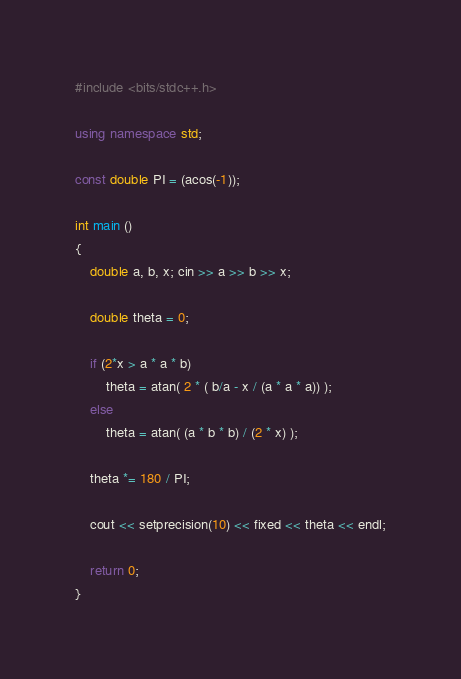Convert code to text. <code><loc_0><loc_0><loc_500><loc_500><_C++_>#include <bits/stdc++.h>

using namespace std;

const double PI = (acos(-1));

int main ()
{
    double a, b, x; cin >> a >> b >> x;

    double theta = 0;

    if (2*x > a * a * b)
        theta = atan( 2 * ( b/a - x / (a * a * a)) );
    else
        theta = atan( (a * b * b) / (2 * x) );

    theta *= 180 / PI;

    cout << setprecision(10) << fixed << theta << endl;

    return 0;
}
</code> 